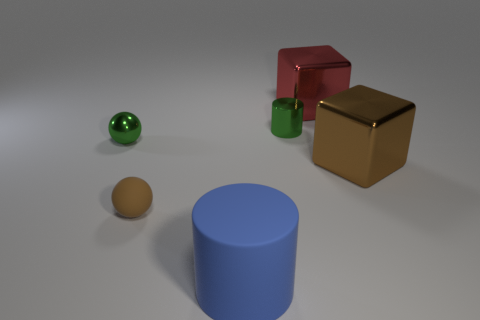Add 3 large rubber cylinders. How many objects exist? 9 Subtract all blocks. How many objects are left? 4 Add 2 green spheres. How many green spheres are left? 3 Add 6 big brown matte objects. How many big brown matte objects exist? 6 Subtract 0 brown cylinders. How many objects are left? 6 Subtract all big red things. Subtract all green metallic spheres. How many objects are left? 4 